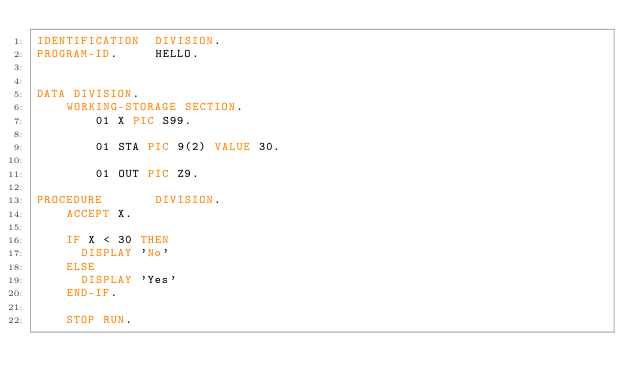<code> <loc_0><loc_0><loc_500><loc_500><_COBOL_>IDENTIFICATION  DIVISION.
PROGRAM-ID.     HELLO.

 
DATA DIVISION.
	WORKING-STORAGE SECTION.
        01 X PIC S99.
        
        01 STA PIC 9(2) VALUE 30.
        
        01 OUT PIC Z9.
      
PROCEDURE       DIVISION.
    ACCEPT X.
    
    IF X < 30 THEN 
      DISPLAY 'No'
    ELSE
      DISPLAY 'Yes'
    END-IF.
    
    STOP RUN.</code> 